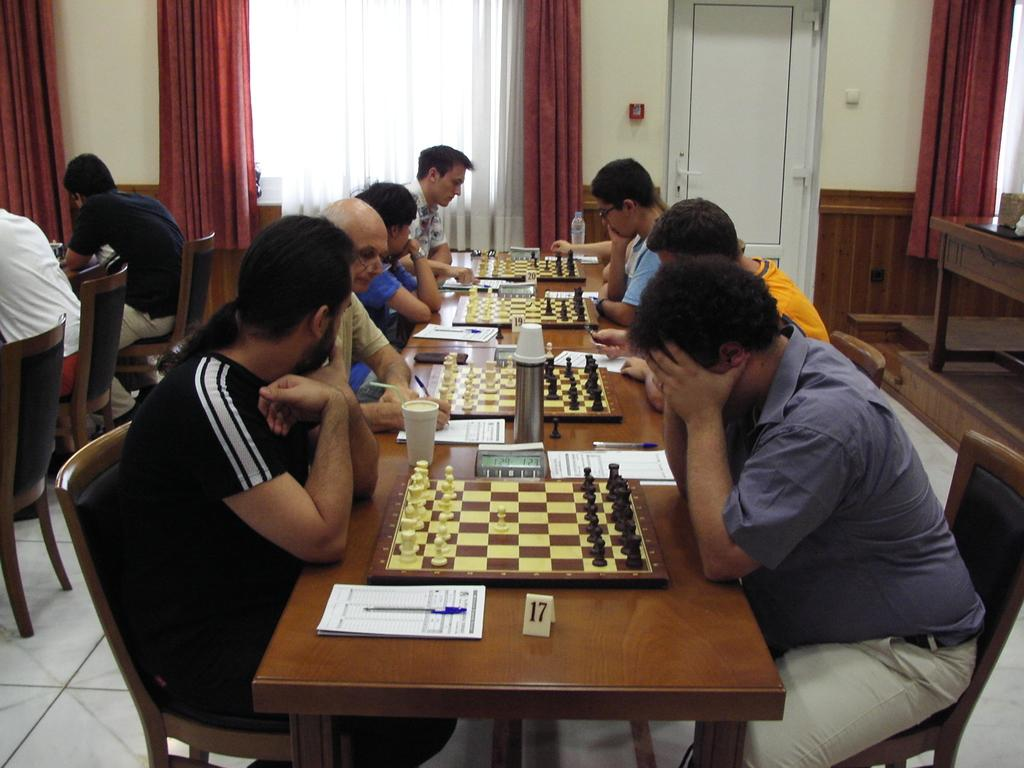How many men are present in the image? There are eight men in the image. What are the men doing in the image? The men are playing chess in four sets. Can you describe the table where the men are sitting? The men are sitting at a long table. What items can be seen on the table besides the chess boards? There are glasses, a flask, stopwatches, and notepads on the table. What type of mint is being used to flavor the chess pieces in the image? There is no mint present in the image, and the chess pieces are not flavored. Can you see a hen in the image? There is no hen present in the image. --- 